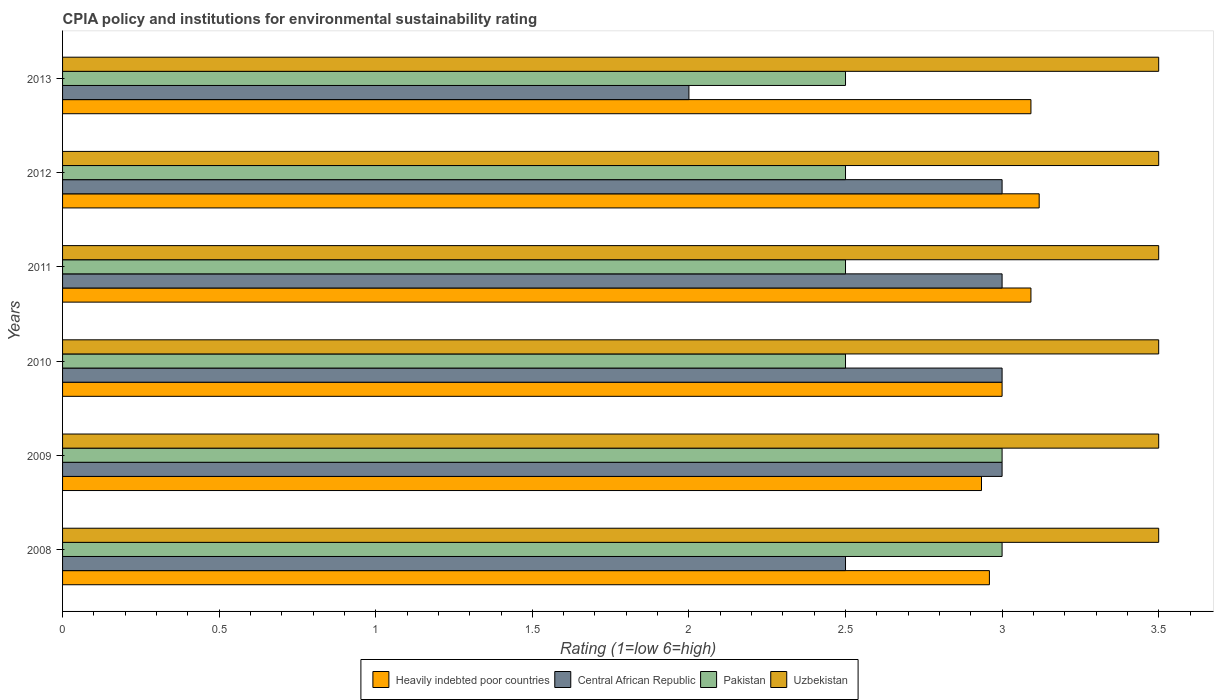Are the number of bars on each tick of the Y-axis equal?
Keep it short and to the point. Yes. How many bars are there on the 5th tick from the bottom?
Your answer should be very brief. 4. In how many cases, is the number of bars for a given year not equal to the number of legend labels?
Offer a terse response. 0. What is the CPIA rating in Uzbekistan in 2011?
Make the answer very short. 3.5. Across all years, what is the maximum CPIA rating in Pakistan?
Provide a short and direct response. 3. Across all years, what is the minimum CPIA rating in Pakistan?
Provide a short and direct response. 2.5. What is the total CPIA rating in Uzbekistan in the graph?
Your answer should be compact. 21. What is the difference between the CPIA rating in Heavily indebted poor countries in 2010 and that in 2013?
Give a very brief answer. -0.09. What is the difference between the CPIA rating in Heavily indebted poor countries in 2010 and the CPIA rating in Uzbekistan in 2011?
Provide a succinct answer. -0.5. What is the average CPIA rating in Pakistan per year?
Keep it short and to the point. 2.67. In the year 2013, what is the difference between the CPIA rating in Uzbekistan and CPIA rating in Heavily indebted poor countries?
Ensure brevity in your answer.  0.41. What is the ratio of the CPIA rating in Central African Republic in 2009 to that in 2011?
Keep it short and to the point. 1. Is the difference between the CPIA rating in Uzbekistan in 2012 and 2013 greater than the difference between the CPIA rating in Heavily indebted poor countries in 2012 and 2013?
Provide a succinct answer. No. What is the difference between the highest and the second highest CPIA rating in Heavily indebted poor countries?
Provide a short and direct response. 0.03. What is the difference between the highest and the lowest CPIA rating in Central African Republic?
Your answer should be very brief. 1. Is the sum of the CPIA rating in Heavily indebted poor countries in 2010 and 2013 greater than the maximum CPIA rating in Uzbekistan across all years?
Make the answer very short. Yes. Is it the case that in every year, the sum of the CPIA rating in Central African Republic and CPIA rating in Uzbekistan is greater than the sum of CPIA rating in Heavily indebted poor countries and CPIA rating in Pakistan?
Provide a short and direct response. No. What does the 4th bar from the top in 2013 represents?
Keep it short and to the point. Heavily indebted poor countries. What does the 2nd bar from the bottom in 2012 represents?
Offer a very short reply. Central African Republic. Is it the case that in every year, the sum of the CPIA rating in Uzbekistan and CPIA rating in Pakistan is greater than the CPIA rating in Central African Republic?
Provide a short and direct response. Yes. How many bars are there?
Offer a terse response. 24. Are all the bars in the graph horizontal?
Your answer should be very brief. Yes. What is the difference between two consecutive major ticks on the X-axis?
Make the answer very short. 0.5. Are the values on the major ticks of X-axis written in scientific E-notation?
Make the answer very short. No. Does the graph contain grids?
Make the answer very short. No. How are the legend labels stacked?
Your response must be concise. Horizontal. What is the title of the graph?
Your response must be concise. CPIA policy and institutions for environmental sustainability rating. Does "Mauritius" appear as one of the legend labels in the graph?
Provide a short and direct response. No. What is the Rating (1=low 6=high) in Heavily indebted poor countries in 2008?
Provide a succinct answer. 2.96. What is the Rating (1=low 6=high) of Pakistan in 2008?
Ensure brevity in your answer.  3. What is the Rating (1=low 6=high) in Heavily indebted poor countries in 2009?
Make the answer very short. 2.93. What is the Rating (1=low 6=high) in Uzbekistan in 2009?
Make the answer very short. 3.5. What is the Rating (1=low 6=high) of Uzbekistan in 2010?
Your response must be concise. 3.5. What is the Rating (1=low 6=high) of Heavily indebted poor countries in 2011?
Your answer should be compact. 3.09. What is the Rating (1=low 6=high) in Pakistan in 2011?
Your answer should be very brief. 2.5. What is the Rating (1=low 6=high) of Heavily indebted poor countries in 2012?
Ensure brevity in your answer.  3.12. What is the Rating (1=low 6=high) of Central African Republic in 2012?
Give a very brief answer. 3. What is the Rating (1=low 6=high) in Pakistan in 2012?
Your response must be concise. 2.5. What is the Rating (1=low 6=high) of Uzbekistan in 2012?
Give a very brief answer. 3.5. What is the Rating (1=low 6=high) of Heavily indebted poor countries in 2013?
Offer a terse response. 3.09. What is the Rating (1=low 6=high) in Uzbekistan in 2013?
Give a very brief answer. 3.5. Across all years, what is the maximum Rating (1=low 6=high) of Heavily indebted poor countries?
Give a very brief answer. 3.12. Across all years, what is the maximum Rating (1=low 6=high) in Central African Republic?
Make the answer very short. 3. Across all years, what is the maximum Rating (1=low 6=high) of Pakistan?
Offer a terse response. 3. Across all years, what is the maximum Rating (1=low 6=high) in Uzbekistan?
Keep it short and to the point. 3.5. Across all years, what is the minimum Rating (1=low 6=high) of Heavily indebted poor countries?
Your response must be concise. 2.93. Across all years, what is the minimum Rating (1=low 6=high) of Central African Republic?
Your response must be concise. 2. Across all years, what is the minimum Rating (1=low 6=high) in Pakistan?
Your answer should be very brief. 2.5. Across all years, what is the minimum Rating (1=low 6=high) of Uzbekistan?
Offer a terse response. 3.5. What is the total Rating (1=low 6=high) in Heavily indebted poor countries in the graph?
Keep it short and to the point. 18.2. What is the total Rating (1=low 6=high) of Pakistan in the graph?
Offer a terse response. 16. What is the total Rating (1=low 6=high) in Uzbekistan in the graph?
Give a very brief answer. 21. What is the difference between the Rating (1=low 6=high) in Heavily indebted poor countries in 2008 and that in 2009?
Provide a short and direct response. 0.03. What is the difference between the Rating (1=low 6=high) of Central African Republic in 2008 and that in 2009?
Provide a succinct answer. -0.5. What is the difference between the Rating (1=low 6=high) of Heavily indebted poor countries in 2008 and that in 2010?
Provide a short and direct response. -0.04. What is the difference between the Rating (1=low 6=high) of Heavily indebted poor countries in 2008 and that in 2011?
Give a very brief answer. -0.13. What is the difference between the Rating (1=low 6=high) of Central African Republic in 2008 and that in 2011?
Offer a very short reply. -0.5. What is the difference between the Rating (1=low 6=high) in Pakistan in 2008 and that in 2011?
Your response must be concise. 0.5. What is the difference between the Rating (1=low 6=high) of Uzbekistan in 2008 and that in 2011?
Your answer should be compact. 0. What is the difference between the Rating (1=low 6=high) of Heavily indebted poor countries in 2008 and that in 2012?
Provide a short and direct response. -0.16. What is the difference between the Rating (1=low 6=high) of Central African Republic in 2008 and that in 2012?
Your answer should be compact. -0.5. What is the difference between the Rating (1=low 6=high) in Uzbekistan in 2008 and that in 2012?
Ensure brevity in your answer.  0. What is the difference between the Rating (1=low 6=high) of Heavily indebted poor countries in 2008 and that in 2013?
Your answer should be compact. -0.13. What is the difference between the Rating (1=low 6=high) in Pakistan in 2008 and that in 2013?
Make the answer very short. 0.5. What is the difference between the Rating (1=low 6=high) of Uzbekistan in 2008 and that in 2013?
Make the answer very short. 0. What is the difference between the Rating (1=low 6=high) of Heavily indebted poor countries in 2009 and that in 2010?
Your answer should be very brief. -0.07. What is the difference between the Rating (1=low 6=high) of Central African Republic in 2009 and that in 2010?
Your answer should be very brief. 0. What is the difference between the Rating (1=low 6=high) in Pakistan in 2009 and that in 2010?
Your answer should be compact. 0.5. What is the difference between the Rating (1=low 6=high) of Uzbekistan in 2009 and that in 2010?
Ensure brevity in your answer.  0. What is the difference between the Rating (1=low 6=high) in Heavily indebted poor countries in 2009 and that in 2011?
Give a very brief answer. -0.16. What is the difference between the Rating (1=low 6=high) of Pakistan in 2009 and that in 2011?
Offer a terse response. 0.5. What is the difference between the Rating (1=low 6=high) in Heavily indebted poor countries in 2009 and that in 2012?
Offer a terse response. -0.18. What is the difference between the Rating (1=low 6=high) in Pakistan in 2009 and that in 2012?
Give a very brief answer. 0.5. What is the difference between the Rating (1=low 6=high) of Uzbekistan in 2009 and that in 2012?
Keep it short and to the point. 0. What is the difference between the Rating (1=low 6=high) of Heavily indebted poor countries in 2009 and that in 2013?
Your response must be concise. -0.16. What is the difference between the Rating (1=low 6=high) of Pakistan in 2009 and that in 2013?
Offer a terse response. 0.5. What is the difference between the Rating (1=low 6=high) of Uzbekistan in 2009 and that in 2013?
Make the answer very short. 0. What is the difference between the Rating (1=low 6=high) of Heavily indebted poor countries in 2010 and that in 2011?
Keep it short and to the point. -0.09. What is the difference between the Rating (1=low 6=high) in Heavily indebted poor countries in 2010 and that in 2012?
Offer a very short reply. -0.12. What is the difference between the Rating (1=low 6=high) in Central African Republic in 2010 and that in 2012?
Your answer should be compact. 0. What is the difference between the Rating (1=low 6=high) in Heavily indebted poor countries in 2010 and that in 2013?
Provide a succinct answer. -0.09. What is the difference between the Rating (1=low 6=high) in Heavily indebted poor countries in 2011 and that in 2012?
Keep it short and to the point. -0.03. What is the difference between the Rating (1=low 6=high) of Central African Republic in 2011 and that in 2012?
Give a very brief answer. 0. What is the difference between the Rating (1=low 6=high) in Heavily indebted poor countries in 2011 and that in 2013?
Give a very brief answer. 0. What is the difference between the Rating (1=low 6=high) of Uzbekistan in 2011 and that in 2013?
Your answer should be compact. 0. What is the difference between the Rating (1=low 6=high) of Heavily indebted poor countries in 2012 and that in 2013?
Offer a very short reply. 0.03. What is the difference between the Rating (1=low 6=high) of Uzbekistan in 2012 and that in 2013?
Make the answer very short. 0. What is the difference between the Rating (1=low 6=high) of Heavily indebted poor countries in 2008 and the Rating (1=low 6=high) of Central African Republic in 2009?
Your answer should be very brief. -0.04. What is the difference between the Rating (1=low 6=high) of Heavily indebted poor countries in 2008 and the Rating (1=low 6=high) of Pakistan in 2009?
Ensure brevity in your answer.  -0.04. What is the difference between the Rating (1=low 6=high) of Heavily indebted poor countries in 2008 and the Rating (1=low 6=high) of Uzbekistan in 2009?
Your answer should be very brief. -0.54. What is the difference between the Rating (1=low 6=high) of Central African Republic in 2008 and the Rating (1=low 6=high) of Uzbekistan in 2009?
Give a very brief answer. -1. What is the difference between the Rating (1=low 6=high) of Pakistan in 2008 and the Rating (1=low 6=high) of Uzbekistan in 2009?
Provide a succinct answer. -0.5. What is the difference between the Rating (1=low 6=high) of Heavily indebted poor countries in 2008 and the Rating (1=low 6=high) of Central African Republic in 2010?
Give a very brief answer. -0.04. What is the difference between the Rating (1=low 6=high) of Heavily indebted poor countries in 2008 and the Rating (1=low 6=high) of Pakistan in 2010?
Make the answer very short. 0.46. What is the difference between the Rating (1=low 6=high) in Heavily indebted poor countries in 2008 and the Rating (1=low 6=high) in Uzbekistan in 2010?
Your answer should be very brief. -0.54. What is the difference between the Rating (1=low 6=high) of Central African Republic in 2008 and the Rating (1=low 6=high) of Uzbekistan in 2010?
Offer a terse response. -1. What is the difference between the Rating (1=low 6=high) in Heavily indebted poor countries in 2008 and the Rating (1=low 6=high) in Central African Republic in 2011?
Your answer should be compact. -0.04. What is the difference between the Rating (1=low 6=high) of Heavily indebted poor countries in 2008 and the Rating (1=low 6=high) of Pakistan in 2011?
Your answer should be very brief. 0.46. What is the difference between the Rating (1=low 6=high) of Heavily indebted poor countries in 2008 and the Rating (1=low 6=high) of Uzbekistan in 2011?
Provide a short and direct response. -0.54. What is the difference between the Rating (1=low 6=high) of Central African Republic in 2008 and the Rating (1=low 6=high) of Pakistan in 2011?
Offer a very short reply. 0. What is the difference between the Rating (1=low 6=high) in Central African Republic in 2008 and the Rating (1=low 6=high) in Uzbekistan in 2011?
Your answer should be very brief. -1. What is the difference between the Rating (1=low 6=high) of Pakistan in 2008 and the Rating (1=low 6=high) of Uzbekistan in 2011?
Offer a terse response. -0.5. What is the difference between the Rating (1=low 6=high) in Heavily indebted poor countries in 2008 and the Rating (1=low 6=high) in Central African Republic in 2012?
Your answer should be compact. -0.04. What is the difference between the Rating (1=low 6=high) in Heavily indebted poor countries in 2008 and the Rating (1=low 6=high) in Pakistan in 2012?
Keep it short and to the point. 0.46. What is the difference between the Rating (1=low 6=high) in Heavily indebted poor countries in 2008 and the Rating (1=low 6=high) in Uzbekistan in 2012?
Give a very brief answer. -0.54. What is the difference between the Rating (1=low 6=high) in Heavily indebted poor countries in 2008 and the Rating (1=low 6=high) in Central African Republic in 2013?
Provide a succinct answer. 0.96. What is the difference between the Rating (1=low 6=high) of Heavily indebted poor countries in 2008 and the Rating (1=low 6=high) of Pakistan in 2013?
Your response must be concise. 0.46. What is the difference between the Rating (1=low 6=high) of Heavily indebted poor countries in 2008 and the Rating (1=low 6=high) of Uzbekistan in 2013?
Ensure brevity in your answer.  -0.54. What is the difference between the Rating (1=low 6=high) in Central African Republic in 2008 and the Rating (1=low 6=high) in Pakistan in 2013?
Keep it short and to the point. 0. What is the difference between the Rating (1=low 6=high) of Heavily indebted poor countries in 2009 and the Rating (1=low 6=high) of Central African Republic in 2010?
Offer a terse response. -0.07. What is the difference between the Rating (1=low 6=high) of Heavily indebted poor countries in 2009 and the Rating (1=low 6=high) of Pakistan in 2010?
Your response must be concise. 0.43. What is the difference between the Rating (1=low 6=high) in Heavily indebted poor countries in 2009 and the Rating (1=low 6=high) in Uzbekistan in 2010?
Offer a terse response. -0.57. What is the difference between the Rating (1=low 6=high) of Central African Republic in 2009 and the Rating (1=low 6=high) of Pakistan in 2010?
Provide a succinct answer. 0.5. What is the difference between the Rating (1=low 6=high) of Heavily indebted poor countries in 2009 and the Rating (1=low 6=high) of Central African Republic in 2011?
Give a very brief answer. -0.07. What is the difference between the Rating (1=low 6=high) of Heavily indebted poor countries in 2009 and the Rating (1=low 6=high) of Pakistan in 2011?
Keep it short and to the point. 0.43. What is the difference between the Rating (1=low 6=high) of Heavily indebted poor countries in 2009 and the Rating (1=low 6=high) of Uzbekistan in 2011?
Ensure brevity in your answer.  -0.57. What is the difference between the Rating (1=low 6=high) of Central African Republic in 2009 and the Rating (1=low 6=high) of Pakistan in 2011?
Ensure brevity in your answer.  0.5. What is the difference between the Rating (1=low 6=high) of Central African Republic in 2009 and the Rating (1=low 6=high) of Uzbekistan in 2011?
Offer a very short reply. -0.5. What is the difference between the Rating (1=low 6=high) of Pakistan in 2009 and the Rating (1=low 6=high) of Uzbekistan in 2011?
Your answer should be compact. -0.5. What is the difference between the Rating (1=low 6=high) in Heavily indebted poor countries in 2009 and the Rating (1=low 6=high) in Central African Republic in 2012?
Your answer should be compact. -0.07. What is the difference between the Rating (1=low 6=high) of Heavily indebted poor countries in 2009 and the Rating (1=low 6=high) of Pakistan in 2012?
Ensure brevity in your answer.  0.43. What is the difference between the Rating (1=low 6=high) in Heavily indebted poor countries in 2009 and the Rating (1=low 6=high) in Uzbekistan in 2012?
Offer a terse response. -0.57. What is the difference between the Rating (1=low 6=high) of Central African Republic in 2009 and the Rating (1=low 6=high) of Pakistan in 2012?
Give a very brief answer. 0.5. What is the difference between the Rating (1=low 6=high) of Heavily indebted poor countries in 2009 and the Rating (1=low 6=high) of Central African Republic in 2013?
Ensure brevity in your answer.  0.93. What is the difference between the Rating (1=low 6=high) in Heavily indebted poor countries in 2009 and the Rating (1=low 6=high) in Pakistan in 2013?
Provide a short and direct response. 0.43. What is the difference between the Rating (1=low 6=high) of Heavily indebted poor countries in 2009 and the Rating (1=low 6=high) of Uzbekistan in 2013?
Give a very brief answer. -0.57. What is the difference between the Rating (1=low 6=high) of Central African Republic in 2009 and the Rating (1=low 6=high) of Pakistan in 2013?
Offer a terse response. 0.5. What is the difference between the Rating (1=low 6=high) in Pakistan in 2009 and the Rating (1=low 6=high) in Uzbekistan in 2013?
Make the answer very short. -0.5. What is the difference between the Rating (1=low 6=high) in Heavily indebted poor countries in 2010 and the Rating (1=low 6=high) in Central African Republic in 2011?
Offer a very short reply. 0. What is the difference between the Rating (1=low 6=high) in Heavily indebted poor countries in 2010 and the Rating (1=low 6=high) in Pakistan in 2011?
Make the answer very short. 0.5. What is the difference between the Rating (1=low 6=high) of Central African Republic in 2010 and the Rating (1=low 6=high) of Pakistan in 2011?
Offer a very short reply. 0.5. What is the difference between the Rating (1=low 6=high) of Heavily indebted poor countries in 2010 and the Rating (1=low 6=high) of Central African Republic in 2012?
Ensure brevity in your answer.  0. What is the difference between the Rating (1=low 6=high) in Heavily indebted poor countries in 2010 and the Rating (1=low 6=high) in Pakistan in 2013?
Your answer should be very brief. 0.5. What is the difference between the Rating (1=low 6=high) of Central African Republic in 2010 and the Rating (1=low 6=high) of Pakistan in 2013?
Your answer should be very brief. 0.5. What is the difference between the Rating (1=low 6=high) of Heavily indebted poor countries in 2011 and the Rating (1=low 6=high) of Central African Republic in 2012?
Make the answer very short. 0.09. What is the difference between the Rating (1=low 6=high) of Heavily indebted poor countries in 2011 and the Rating (1=low 6=high) of Pakistan in 2012?
Your answer should be compact. 0.59. What is the difference between the Rating (1=low 6=high) of Heavily indebted poor countries in 2011 and the Rating (1=low 6=high) of Uzbekistan in 2012?
Your answer should be very brief. -0.41. What is the difference between the Rating (1=low 6=high) in Pakistan in 2011 and the Rating (1=low 6=high) in Uzbekistan in 2012?
Offer a terse response. -1. What is the difference between the Rating (1=low 6=high) in Heavily indebted poor countries in 2011 and the Rating (1=low 6=high) in Central African Republic in 2013?
Provide a succinct answer. 1.09. What is the difference between the Rating (1=low 6=high) of Heavily indebted poor countries in 2011 and the Rating (1=low 6=high) of Pakistan in 2013?
Offer a very short reply. 0.59. What is the difference between the Rating (1=low 6=high) of Heavily indebted poor countries in 2011 and the Rating (1=low 6=high) of Uzbekistan in 2013?
Provide a short and direct response. -0.41. What is the difference between the Rating (1=low 6=high) in Pakistan in 2011 and the Rating (1=low 6=high) in Uzbekistan in 2013?
Your answer should be very brief. -1. What is the difference between the Rating (1=low 6=high) of Heavily indebted poor countries in 2012 and the Rating (1=low 6=high) of Central African Republic in 2013?
Your answer should be compact. 1.12. What is the difference between the Rating (1=low 6=high) in Heavily indebted poor countries in 2012 and the Rating (1=low 6=high) in Pakistan in 2013?
Give a very brief answer. 0.62. What is the difference between the Rating (1=low 6=high) of Heavily indebted poor countries in 2012 and the Rating (1=low 6=high) of Uzbekistan in 2013?
Make the answer very short. -0.38. What is the difference between the Rating (1=low 6=high) of Central African Republic in 2012 and the Rating (1=low 6=high) of Uzbekistan in 2013?
Offer a very short reply. -0.5. What is the average Rating (1=low 6=high) in Heavily indebted poor countries per year?
Your answer should be compact. 3.03. What is the average Rating (1=low 6=high) of Central African Republic per year?
Ensure brevity in your answer.  2.75. What is the average Rating (1=low 6=high) in Pakistan per year?
Offer a terse response. 2.67. What is the average Rating (1=low 6=high) of Uzbekistan per year?
Ensure brevity in your answer.  3.5. In the year 2008, what is the difference between the Rating (1=low 6=high) in Heavily indebted poor countries and Rating (1=low 6=high) in Central African Republic?
Ensure brevity in your answer.  0.46. In the year 2008, what is the difference between the Rating (1=low 6=high) in Heavily indebted poor countries and Rating (1=low 6=high) in Pakistan?
Provide a short and direct response. -0.04. In the year 2008, what is the difference between the Rating (1=low 6=high) in Heavily indebted poor countries and Rating (1=low 6=high) in Uzbekistan?
Give a very brief answer. -0.54. In the year 2008, what is the difference between the Rating (1=low 6=high) of Central African Republic and Rating (1=low 6=high) of Pakistan?
Provide a succinct answer. -0.5. In the year 2008, what is the difference between the Rating (1=low 6=high) in Central African Republic and Rating (1=low 6=high) in Uzbekistan?
Keep it short and to the point. -1. In the year 2008, what is the difference between the Rating (1=low 6=high) of Pakistan and Rating (1=low 6=high) of Uzbekistan?
Your answer should be compact. -0.5. In the year 2009, what is the difference between the Rating (1=low 6=high) in Heavily indebted poor countries and Rating (1=low 6=high) in Central African Republic?
Offer a terse response. -0.07. In the year 2009, what is the difference between the Rating (1=low 6=high) of Heavily indebted poor countries and Rating (1=low 6=high) of Pakistan?
Make the answer very short. -0.07. In the year 2009, what is the difference between the Rating (1=low 6=high) of Heavily indebted poor countries and Rating (1=low 6=high) of Uzbekistan?
Give a very brief answer. -0.57. In the year 2009, what is the difference between the Rating (1=low 6=high) in Central African Republic and Rating (1=low 6=high) in Pakistan?
Your response must be concise. 0. In the year 2009, what is the difference between the Rating (1=low 6=high) of Central African Republic and Rating (1=low 6=high) of Uzbekistan?
Offer a terse response. -0.5. In the year 2010, what is the difference between the Rating (1=low 6=high) of Heavily indebted poor countries and Rating (1=low 6=high) of Central African Republic?
Offer a very short reply. 0. In the year 2010, what is the difference between the Rating (1=low 6=high) of Heavily indebted poor countries and Rating (1=low 6=high) of Uzbekistan?
Your response must be concise. -0.5. In the year 2010, what is the difference between the Rating (1=low 6=high) in Central African Republic and Rating (1=low 6=high) in Uzbekistan?
Give a very brief answer. -0.5. In the year 2011, what is the difference between the Rating (1=low 6=high) of Heavily indebted poor countries and Rating (1=low 6=high) of Central African Republic?
Your answer should be very brief. 0.09. In the year 2011, what is the difference between the Rating (1=low 6=high) in Heavily indebted poor countries and Rating (1=low 6=high) in Pakistan?
Give a very brief answer. 0.59. In the year 2011, what is the difference between the Rating (1=low 6=high) of Heavily indebted poor countries and Rating (1=low 6=high) of Uzbekistan?
Offer a terse response. -0.41. In the year 2011, what is the difference between the Rating (1=low 6=high) in Central African Republic and Rating (1=low 6=high) in Uzbekistan?
Provide a short and direct response. -0.5. In the year 2011, what is the difference between the Rating (1=low 6=high) of Pakistan and Rating (1=low 6=high) of Uzbekistan?
Give a very brief answer. -1. In the year 2012, what is the difference between the Rating (1=low 6=high) in Heavily indebted poor countries and Rating (1=low 6=high) in Central African Republic?
Offer a terse response. 0.12. In the year 2012, what is the difference between the Rating (1=low 6=high) of Heavily indebted poor countries and Rating (1=low 6=high) of Pakistan?
Ensure brevity in your answer.  0.62. In the year 2012, what is the difference between the Rating (1=low 6=high) in Heavily indebted poor countries and Rating (1=low 6=high) in Uzbekistan?
Offer a terse response. -0.38. In the year 2012, what is the difference between the Rating (1=low 6=high) in Central African Republic and Rating (1=low 6=high) in Pakistan?
Keep it short and to the point. 0.5. In the year 2013, what is the difference between the Rating (1=low 6=high) of Heavily indebted poor countries and Rating (1=low 6=high) of Central African Republic?
Your response must be concise. 1.09. In the year 2013, what is the difference between the Rating (1=low 6=high) of Heavily indebted poor countries and Rating (1=low 6=high) of Pakistan?
Your response must be concise. 0.59. In the year 2013, what is the difference between the Rating (1=low 6=high) of Heavily indebted poor countries and Rating (1=low 6=high) of Uzbekistan?
Offer a terse response. -0.41. In the year 2013, what is the difference between the Rating (1=low 6=high) in Central African Republic and Rating (1=low 6=high) in Uzbekistan?
Keep it short and to the point. -1.5. In the year 2013, what is the difference between the Rating (1=low 6=high) of Pakistan and Rating (1=low 6=high) of Uzbekistan?
Offer a terse response. -1. What is the ratio of the Rating (1=low 6=high) of Heavily indebted poor countries in 2008 to that in 2009?
Provide a succinct answer. 1.01. What is the ratio of the Rating (1=low 6=high) in Heavily indebted poor countries in 2008 to that in 2010?
Offer a very short reply. 0.99. What is the ratio of the Rating (1=low 6=high) in Uzbekistan in 2008 to that in 2010?
Offer a terse response. 1. What is the ratio of the Rating (1=low 6=high) of Heavily indebted poor countries in 2008 to that in 2011?
Provide a succinct answer. 0.96. What is the ratio of the Rating (1=low 6=high) in Central African Republic in 2008 to that in 2011?
Your response must be concise. 0.83. What is the ratio of the Rating (1=low 6=high) of Pakistan in 2008 to that in 2011?
Give a very brief answer. 1.2. What is the ratio of the Rating (1=low 6=high) of Heavily indebted poor countries in 2008 to that in 2012?
Offer a terse response. 0.95. What is the ratio of the Rating (1=low 6=high) of Heavily indebted poor countries in 2008 to that in 2013?
Ensure brevity in your answer.  0.96. What is the ratio of the Rating (1=low 6=high) in Pakistan in 2008 to that in 2013?
Give a very brief answer. 1.2. What is the ratio of the Rating (1=low 6=high) in Heavily indebted poor countries in 2009 to that in 2010?
Provide a succinct answer. 0.98. What is the ratio of the Rating (1=low 6=high) of Uzbekistan in 2009 to that in 2010?
Your response must be concise. 1. What is the ratio of the Rating (1=low 6=high) of Heavily indebted poor countries in 2009 to that in 2011?
Offer a very short reply. 0.95. What is the ratio of the Rating (1=low 6=high) in Pakistan in 2009 to that in 2011?
Provide a short and direct response. 1.2. What is the ratio of the Rating (1=low 6=high) in Uzbekistan in 2009 to that in 2011?
Ensure brevity in your answer.  1. What is the ratio of the Rating (1=low 6=high) in Heavily indebted poor countries in 2009 to that in 2012?
Ensure brevity in your answer.  0.94. What is the ratio of the Rating (1=low 6=high) of Central African Republic in 2009 to that in 2012?
Provide a short and direct response. 1. What is the ratio of the Rating (1=low 6=high) in Uzbekistan in 2009 to that in 2012?
Ensure brevity in your answer.  1. What is the ratio of the Rating (1=low 6=high) of Heavily indebted poor countries in 2009 to that in 2013?
Offer a very short reply. 0.95. What is the ratio of the Rating (1=low 6=high) of Central African Republic in 2009 to that in 2013?
Give a very brief answer. 1.5. What is the ratio of the Rating (1=low 6=high) of Pakistan in 2009 to that in 2013?
Ensure brevity in your answer.  1.2. What is the ratio of the Rating (1=low 6=high) of Uzbekistan in 2009 to that in 2013?
Keep it short and to the point. 1. What is the ratio of the Rating (1=low 6=high) in Heavily indebted poor countries in 2010 to that in 2011?
Give a very brief answer. 0.97. What is the ratio of the Rating (1=low 6=high) in Pakistan in 2010 to that in 2011?
Your answer should be compact. 1. What is the ratio of the Rating (1=low 6=high) in Uzbekistan in 2010 to that in 2011?
Provide a succinct answer. 1. What is the ratio of the Rating (1=low 6=high) of Heavily indebted poor countries in 2010 to that in 2012?
Ensure brevity in your answer.  0.96. What is the ratio of the Rating (1=low 6=high) of Pakistan in 2010 to that in 2012?
Make the answer very short. 1. What is the ratio of the Rating (1=low 6=high) of Heavily indebted poor countries in 2010 to that in 2013?
Ensure brevity in your answer.  0.97. What is the ratio of the Rating (1=low 6=high) of Pakistan in 2010 to that in 2013?
Offer a terse response. 1. What is the ratio of the Rating (1=low 6=high) in Heavily indebted poor countries in 2011 to that in 2012?
Your response must be concise. 0.99. What is the ratio of the Rating (1=low 6=high) of Central African Republic in 2011 to that in 2012?
Offer a very short reply. 1. What is the ratio of the Rating (1=low 6=high) in Pakistan in 2011 to that in 2013?
Your answer should be very brief. 1. What is the ratio of the Rating (1=low 6=high) of Heavily indebted poor countries in 2012 to that in 2013?
Give a very brief answer. 1.01. What is the ratio of the Rating (1=low 6=high) of Pakistan in 2012 to that in 2013?
Keep it short and to the point. 1. What is the ratio of the Rating (1=low 6=high) of Uzbekistan in 2012 to that in 2013?
Offer a terse response. 1. What is the difference between the highest and the second highest Rating (1=low 6=high) in Heavily indebted poor countries?
Offer a very short reply. 0.03. What is the difference between the highest and the second highest Rating (1=low 6=high) in Central African Republic?
Your answer should be compact. 0. What is the difference between the highest and the second highest Rating (1=low 6=high) in Uzbekistan?
Ensure brevity in your answer.  0. What is the difference between the highest and the lowest Rating (1=low 6=high) of Heavily indebted poor countries?
Offer a very short reply. 0.18. What is the difference between the highest and the lowest Rating (1=low 6=high) of Central African Republic?
Provide a succinct answer. 1. What is the difference between the highest and the lowest Rating (1=low 6=high) of Pakistan?
Offer a terse response. 0.5. What is the difference between the highest and the lowest Rating (1=low 6=high) of Uzbekistan?
Your response must be concise. 0. 